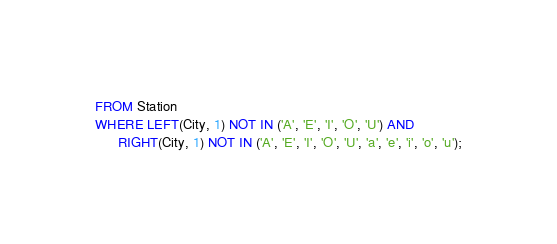Convert code to text. <code><loc_0><loc_0><loc_500><loc_500><_SQL_>FROM Station
WHERE LEFT(City, 1) NOT IN ('A', 'E', 'I', 'O', 'U') AND
      RIGHT(City, 1) NOT IN ('A', 'E', 'I', 'O', 'U', 'a', 'e', 'i', 'o', 'u');
</code> 